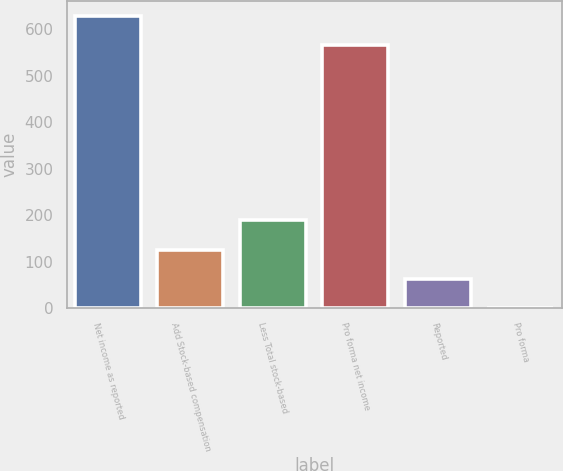Convert chart to OTSL. <chart><loc_0><loc_0><loc_500><loc_500><bar_chart><fcel>Net income as reported<fcel>Add Stock-based compensation<fcel>Less Total stock-based<fcel>Pro forma net income<fcel>Reported<fcel>Pro forma<nl><fcel>629.73<fcel>126.15<fcel>188.88<fcel>567<fcel>63.42<fcel>0.69<nl></chart> 